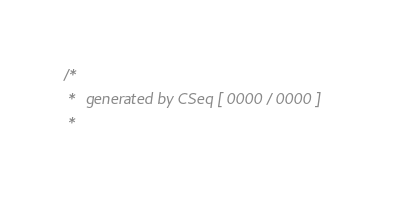Convert code to text. <code><loc_0><loc_0><loc_500><loc_500><_C_>/*
 *  generated by CSeq [ 0000 / 0000 ]
 * </code> 